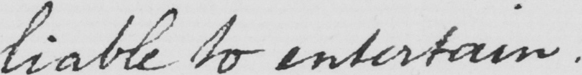Transcribe the text shown in this historical manuscript line. liable to entertain . 